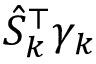<formula> <loc_0><loc_0><loc_500><loc_500>\hat { S } _ { k } ^ { \top } \gamma _ { k }</formula> 